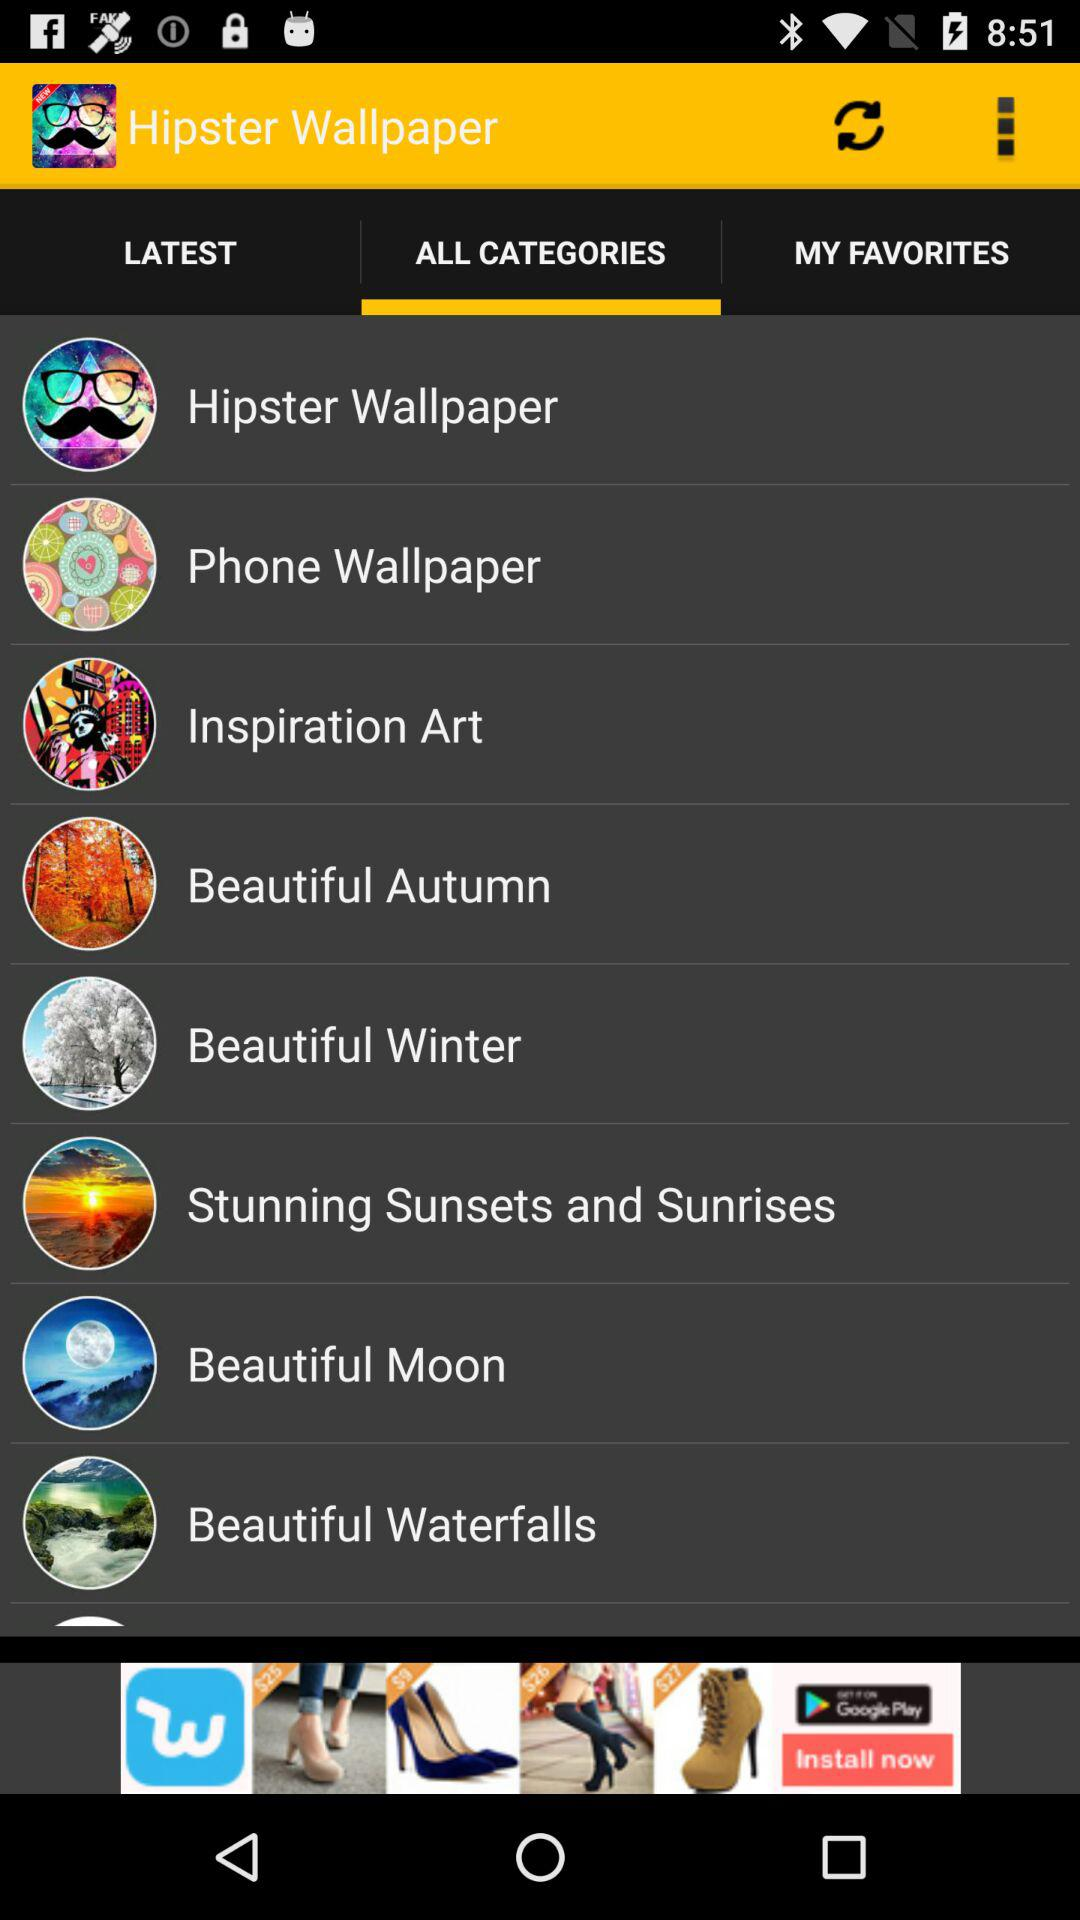Which tab has been selected? The selected tab is "ALL CATEGORIES". 